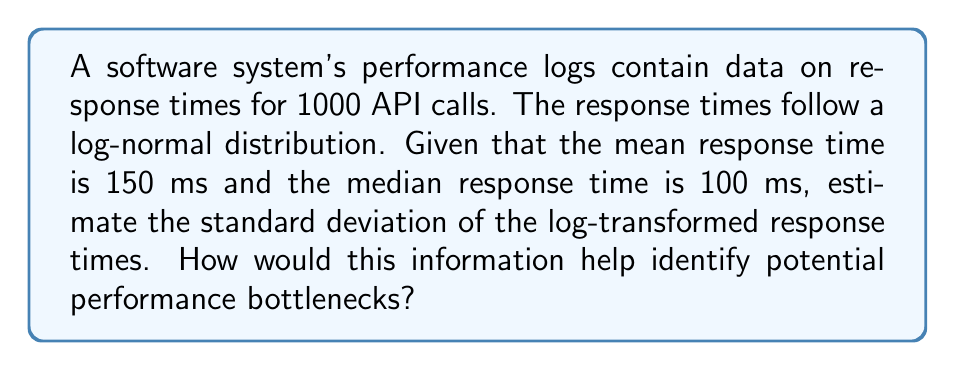Teach me how to tackle this problem. To solve this problem and identify potential performance bottlenecks, let's follow these steps:

1. Recall that for a log-normal distribution:
   - If $X$ is log-normally distributed, then $Y = \ln(X)$ is normally distributed.
   - The median of $X$ is $e^{\mu}$, where $\mu$ is the mean of $Y$.
   - The mean of $X$ is $e^{\mu + \frac{\sigma^2}{2}}$, where $\sigma$ is the standard deviation of $Y$.

2. Given:
   - Median response time = 100 ms
   - Mean response time = 150 ms

3. Calculate $\mu$:
   $e^{\mu} = 100$
   $\mu = \ln(100) = 4.6052$

4. Use the mean to set up an equation:
   $150 = e^{4.6052 + \frac{\sigma^2}{2}}$

5. Solve for $\sigma$:
   $\ln(150) = 4.6052 + \frac{\sigma^2}{2}$
   $5.0106 = 4.6052 + \frac{\sigma^2}{2}$
   $\frac{\sigma^2}{2} = 0.4054$
   $\sigma^2 = 0.8108$
   $\sigma = \sqrt{0.8108} \approx 0.9005$

6. Interpretation for bottleneck identification:
   - The standard deviation of the log-transformed response times (σ ≈ 0.9005) indicates the spread of the data.
   - A larger σ suggests more variability in response times, which could indicate inconsistent performance or potential bottlenecks.
   - By comparing this value to industry standards or historical data, we can determine if the system's performance variability is within acceptable limits.
   - Unusually high σ might suggest investigating factors causing sporadic slowdowns, such as resource contention, inefficient algorithms, or external service dependencies.
Answer: $\sigma \approx 0.9005$ 